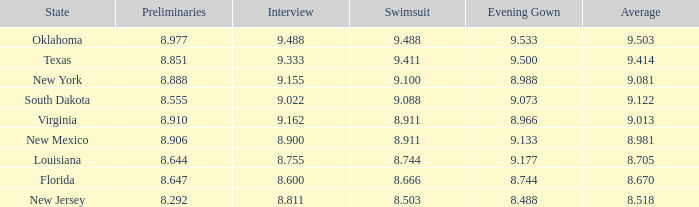 what's the preliminaries where state is south dakota 8.555. 